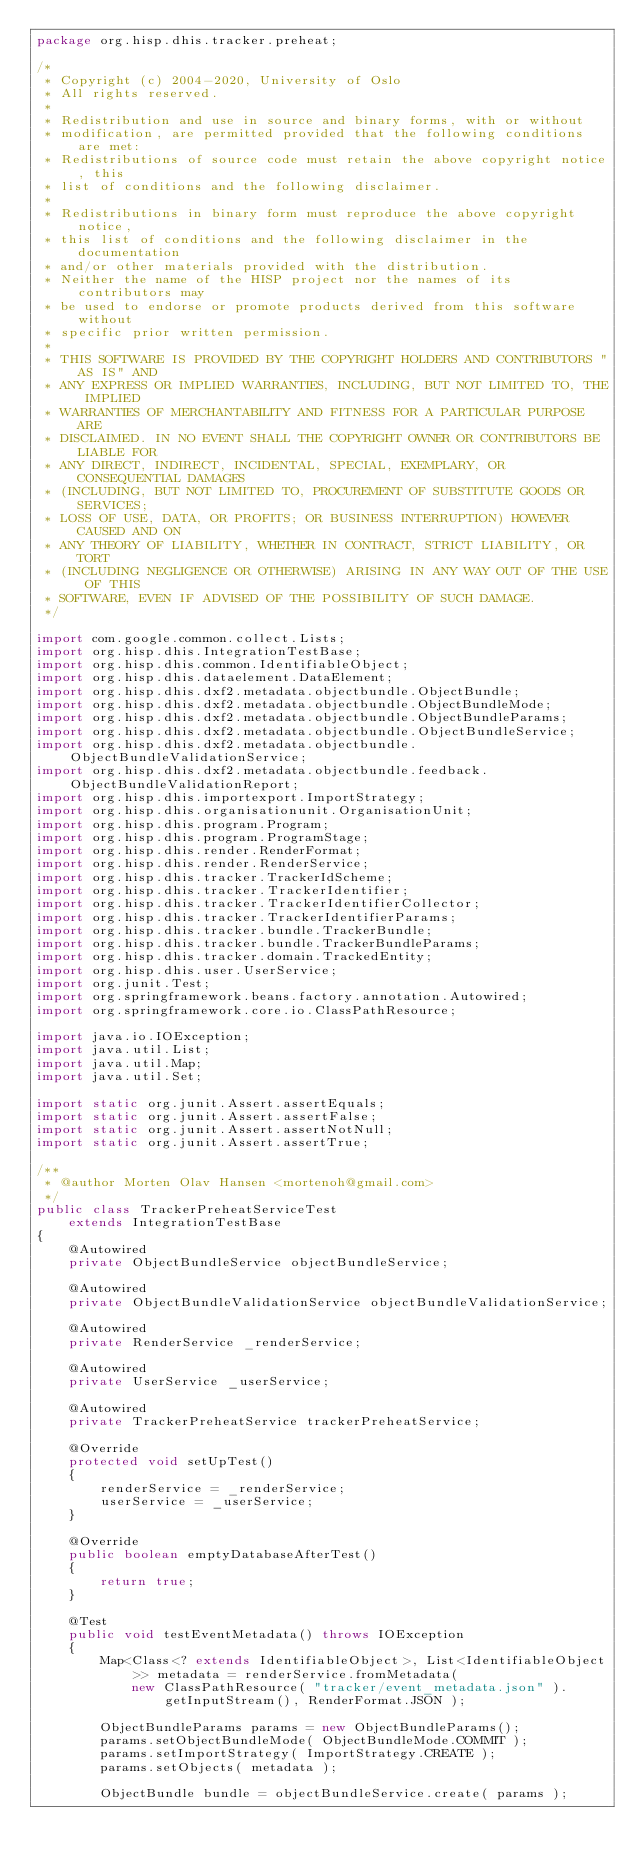Convert code to text. <code><loc_0><loc_0><loc_500><loc_500><_Java_>package org.hisp.dhis.tracker.preheat;

/*
 * Copyright (c) 2004-2020, University of Oslo
 * All rights reserved.
 *
 * Redistribution and use in source and binary forms, with or without
 * modification, are permitted provided that the following conditions are met:
 * Redistributions of source code must retain the above copyright notice, this
 * list of conditions and the following disclaimer.
 *
 * Redistributions in binary form must reproduce the above copyright notice,
 * this list of conditions and the following disclaimer in the documentation
 * and/or other materials provided with the distribution.
 * Neither the name of the HISP project nor the names of its contributors may
 * be used to endorse or promote products derived from this software without
 * specific prior written permission.
 *
 * THIS SOFTWARE IS PROVIDED BY THE COPYRIGHT HOLDERS AND CONTRIBUTORS "AS IS" AND
 * ANY EXPRESS OR IMPLIED WARRANTIES, INCLUDING, BUT NOT LIMITED TO, THE IMPLIED
 * WARRANTIES OF MERCHANTABILITY AND FITNESS FOR A PARTICULAR PURPOSE ARE
 * DISCLAIMED. IN NO EVENT SHALL THE COPYRIGHT OWNER OR CONTRIBUTORS BE LIABLE FOR
 * ANY DIRECT, INDIRECT, INCIDENTAL, SPECIAL, EXEMPLARY, OR CONSEQUENTIAL DAMAGES
 * (INCLUDING, BUT NOT LIMITED TO, PROCUREMENT OF SUBSTITUTE GOODS OR SERVICES;
 * LOSS OF USE, DATA, OR PROFITS; OR BUSINESS INTERRUPTION) HOWEVER CAUSED AND ON
 * ANY THEORY OF LIABILITY, WHETHER IN CONTRACT, STRICT LIABILITY, OR TORT
 * (INCLUDING NEGLIGENCE OR OTHERWISE) ARISING IN ANY WAY OUT OF THE USE OF THIS
 * SOFTWARE, EVEN IF ADVISED OF THE POSSIBILITY OF SUCH DAMAGE.
 */

import com.google.common.collect.Lists;
import org.hisp.dhis.IntegrationTestBase;
import org.hisp.dhis.common.IdentifiableObject;
import org.hisp.dhis.dataelement.DataElement;
import org.hisp.dhis.dxf2.metadata.objectbundle.ObjectBundle;
import org.hisp.dhis.dxf2.metadata.objectbundle.ObjectBundleMode;
import org.hisp.dhis.dxf2.metadata.objectbundle.ObjectBundleParams;
import org.hisp.dhis.dxf2.metadata.objectbundle.ObjectBundleService;
import org.hisp.dhis.dxf2.metadata.objectbundle.ObjectBundleValidationService;
import org.hisp.dhis.dxf2.metadata.objectbundle.feedback.ObjectBundleValidationReport;
import org.hisp.dhis.importexport.ImportStrategy;
import org.hisp.dhis.organisationunit.OrganisationUnit;
import org.hisp.dhis.program.Program;
import org.hisp.dhis.program.ProgramStage;
import org.hisp.dhis.render.RenderFormat;
import org.hisp.dhis.render.RenderService;
import org.hisp.dhis.tracker.TrackerIdScheme;
import org.hisp.dhis.tracker.TrackerIdentifier;
import org.hisp.dhis.tracker.TrackerIdentifierCollector;
import org.hisp.dhis.tracker.TrackerIdentifierParams;
import org.hisp.dhis.tracker.bundle.TrackerBundle;
import org.hisp.dhis.tracker.bundle.TrackerBundleParams;
import org.hisp.dhis.tracker.domain.TrackedEntity;
import org.hisp.dhis.user.UserService;
import org.junit.Test;
import org.springframework.beans.factory.annotation.Autowired;
import org.springframework.core.io.ClassPathResource;

import java.io.IOException;
import java.util.List;
import java.util.Map;
import java.util.Set;

import static org.junit.Assert.assertEquals;
import static org.junit.Assert.assertFalse;
import static org.junit.Assert.assertNotNull;
import static org.junit.Assert.assertTrue;

/**
 * @author Morten Olav Hansen <mortenoh@gmail.com>
 */
public class TrackerPreheatServiceTest
    extends IntegrationTestBase
{
    @Autowired
    private ObjectBundleService objectBundleService;

    @Autowired
    private ObjectBundleValidationService objectBundleValidationService;

    @Autowired
    private RenderService _renderService;

    @Autowired
    private UserService _userService;

    @Autowired
    private TrackerPreheatService trackerPreheatService;

    @Override
    protected void setUpTest()
    {
        renderService = _renderService;
        userService = _userService;
    }

    @Override
    public boolean emptyDatabaseAfterTest()
    {
        return true;
    }

    @Test
    public void testEventMetadata() throws IOException
    {
        Map<Class<? extends IdentifiableObject>, List<IdentifiableObject>> metadata = renderService.fromMetadata(
            new ClassPathResource( "tracker/event_metadata.json" ).getInputStream(), RenderFormat.JSON );

        ObjectBundleParams params = new ObjectBundleParams();
        params.setObjectBundleMode( ObjectBundleMode.COMMIT );
        params.setImportStrategy( ImportStrategy.CREATE );
        params.setObjects( metadata );

        ObjectBundle bundle = objectBundleService.create( params );</code> 